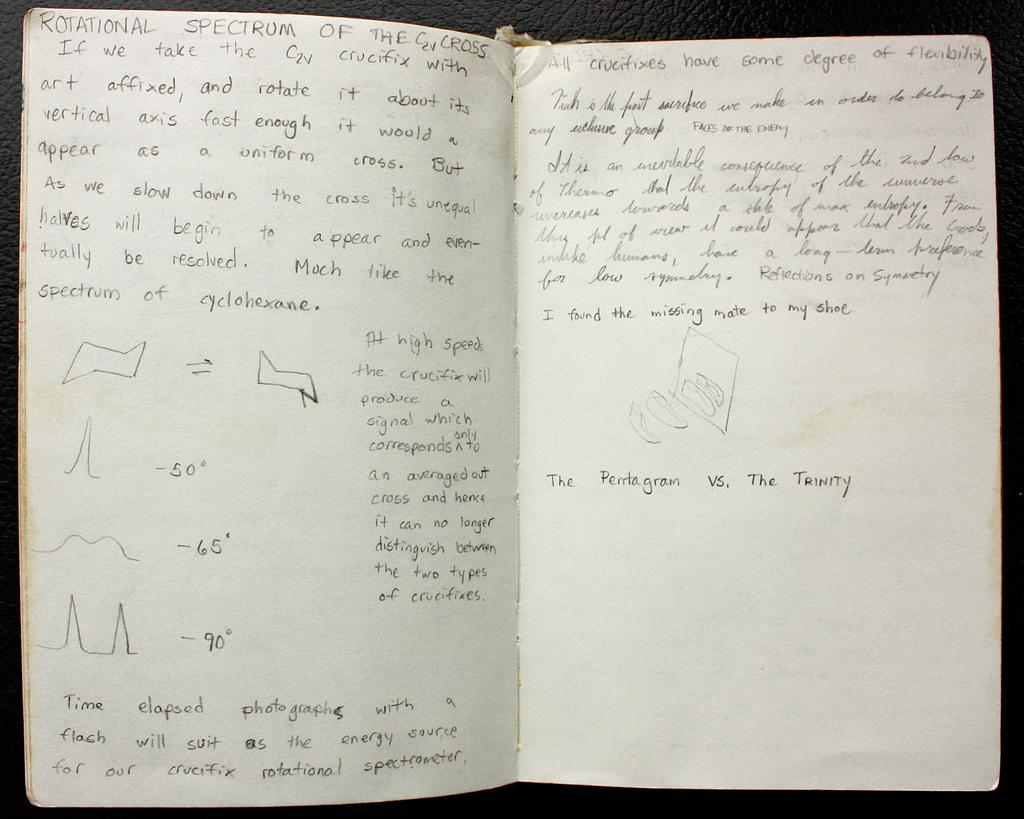The pentagram vs. the what?
Make the answer very short. Trinity. 